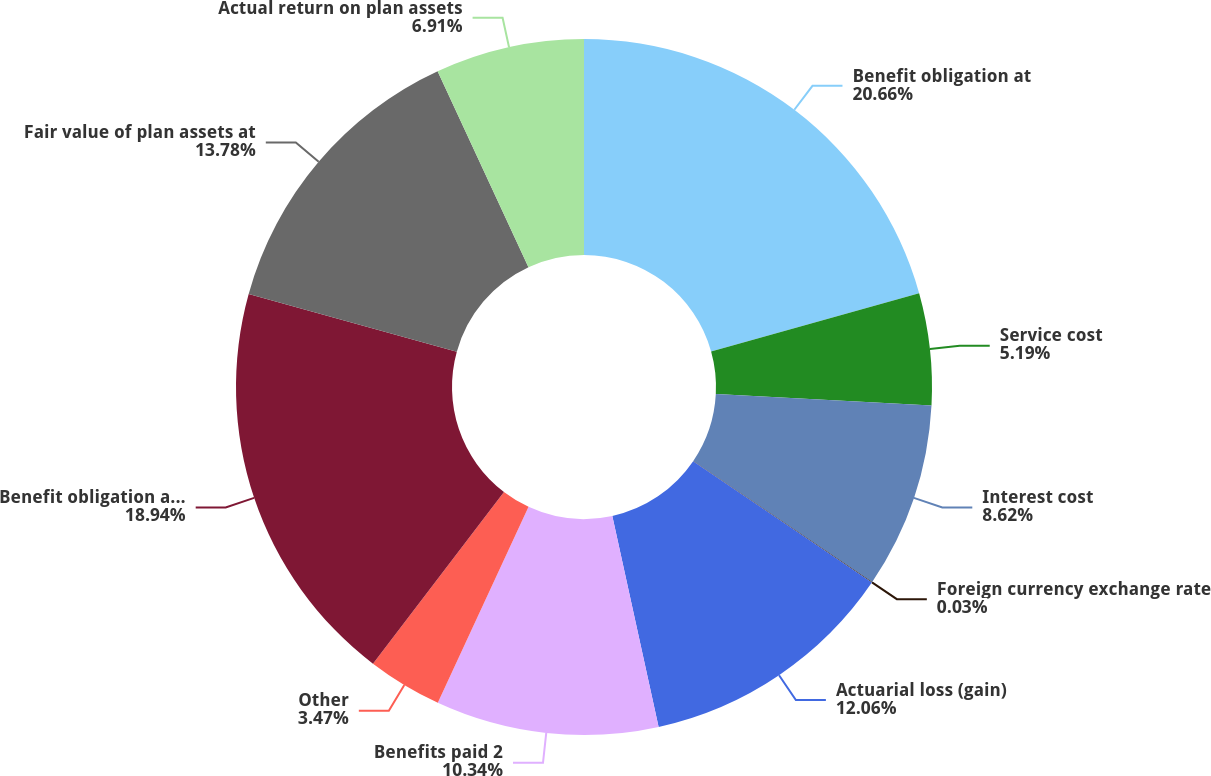<chart> <loc_0><loc_0><loc_500><loc_500><pie_chart><fcel>Benefit obligation at<fcel>Service cost<fcel>Interest cost<fcel>Foreign currency exchange rate<fcel>Actuarial loss (gain)<fcel>Benefits paid 2<fcel>Other<fcel>Benefit obligation at end of<fcel>Fair value of plan assets at<fcel>Actual return on plan assets<nl><fcel>20.66%<fcel>5.19%<fcel>8.62%<fcel>0.03%<fcel>12.06%<fcel>10.34%<fcel>3.47%<fcel>18.94%<fcel>13.78%<fcel>6.91%<nl></chart> 